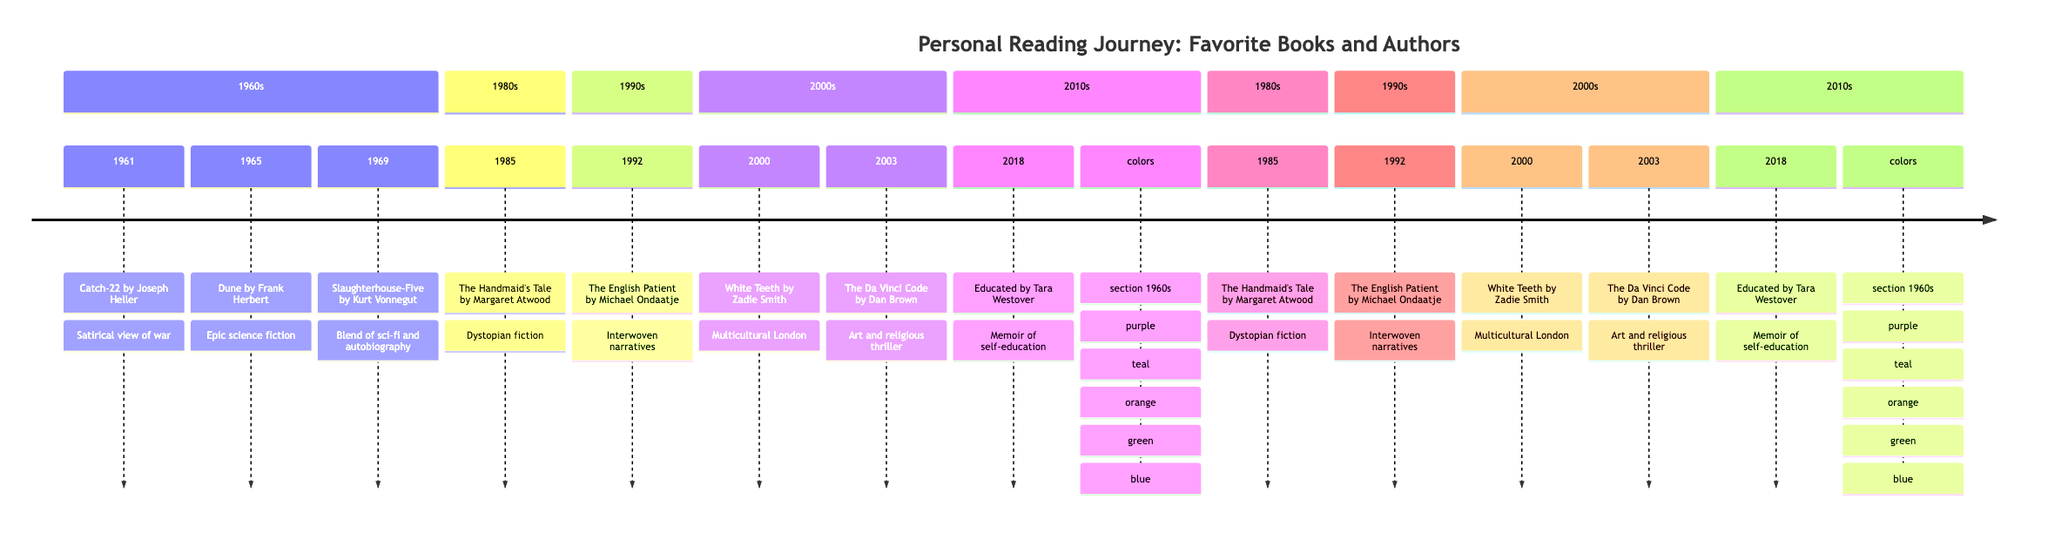What is the title of the book published in 1961? The timeline indicates that the book published in 1961 is "Catch-22." This information is found directly in the section labelled with the year 1961.
Answer: Catch-22 Who is the author of "The Handmaid's Tale"? According to the timeline, "The Handmaid's Tale" was written by Margaret Atwood, as listed in the section for the 1980s, specifically in the year 1985.
Answer: Margaret Atwood How many books are listed from the 2000s? In the timeline under the 2000s section, there are two books: "White Teeth" (2000) and "The Da Vinci Code" (2003), which indicates that a count of the books in this section is two.
Answer: 2 Which book was published in 2003? Referring to the timeline, in the year 2003, the book "The Da Vinci Code" is mentioned, which answers the question regarding the publication year.
Answer: The Da Vinci Code What genre does "Educated" fall under? The timeline indicates that "Educated," published in 2018, is categorized as a memoir. This conclusion is drawn from the notes associated with the book in the timeline.
Answer: Memoir What year was "Slaughterhouse-Five" published? Checking the timeline, "Slaughterhouse-Five" was published in 1969. This date is explicitly stated in the corresponding section for that year.
Answer: 1969 Which author is associated with the book "Dune"? The timeline indicates that Frank Herbert is the author of "Dune," which is mentioned in the 1965 entry. This author-book relationship is clearly marked on the timeline.
Answer: Frank Herbert What is the common theme among the books listed in the 1960s section? Examining the three books from the 1960s ("Catch-22," "Dune," and "Slaughterhouse-Five"), a common theme could be the critique of society and its structures, as each book presents unique perspectives on war, politics, and human experience.
Answer: Critique of society What are the colors associated with the 1980s books? The timeline specifies that the section for the 1980s is colored teal. In any visual representation, this means that the books listed under that section, including "The Handmaid's Tale," share this color theme.
Answer: Teal 